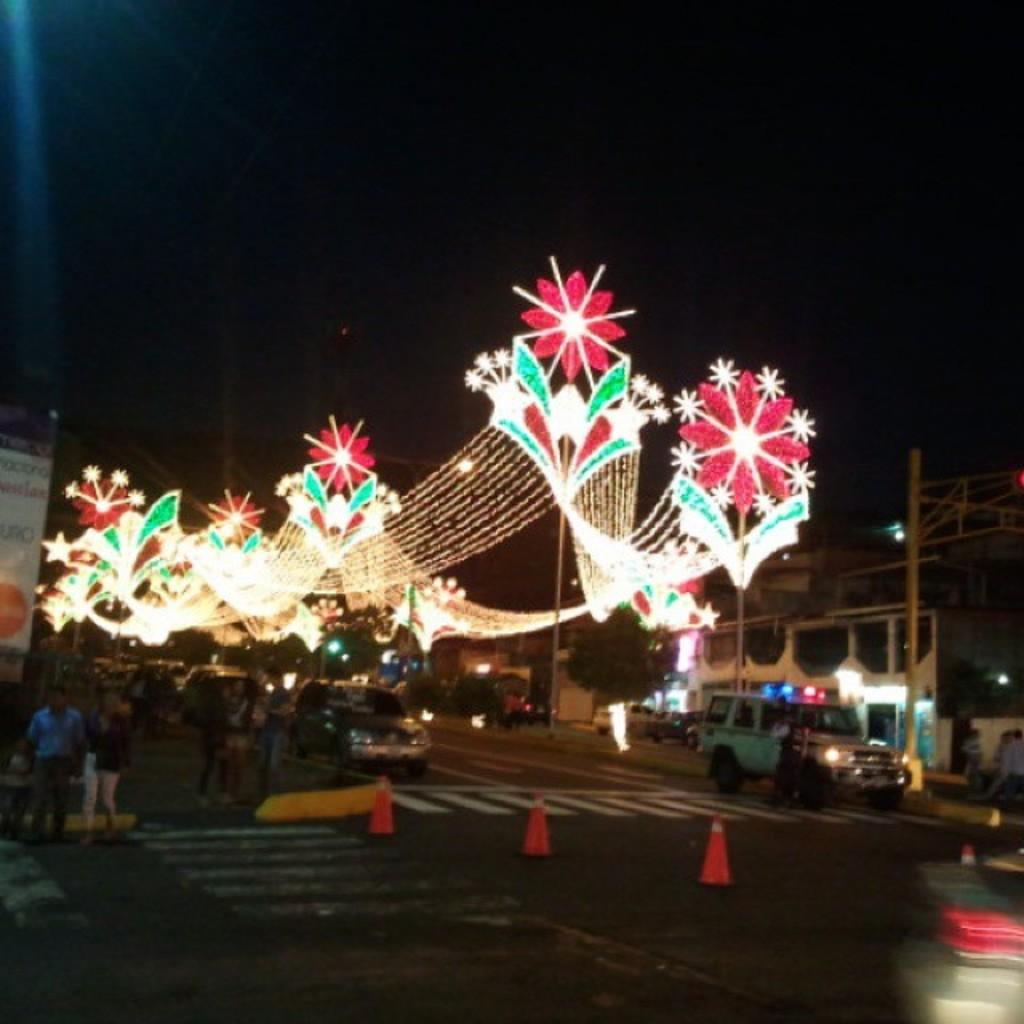What type of structures can be seen in the image? There are buildings in the image. What is happening on the road in the image? Motor vehicles are present on the road, and there are persons standing on the road. What objects are placed on the road in the image? Traffic cones are visible in the image. What additional features can be seen in the image? Decor lights are present in the image. What can be seen in the background of the image? The sky is visible in the image. How far away is the heart visible in the image? There is no heart present in the image. What type of town is depicted in the image? The image does not depict a town; it shows buildings, motor vehicles, persons, traffic cones, decor lights, and the sky. 